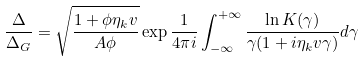Convert formula to latex. <formula><loc_0><loc_0><loc_500><loc_500>\frac { \Delta } { \Delta _ { G } } = \sqrt { \frac { 1 + \phi \eta _ { k } v } { A \phi } } \exp { \frac { 1 } { 4 \pi i } \int _ { - \infty } ^ { + \infty } \frac { \ln K ( \gamma ) } { \gamma ( 1 + i \eta _ { k } v \gamma ) } d \gamma }</formula> 